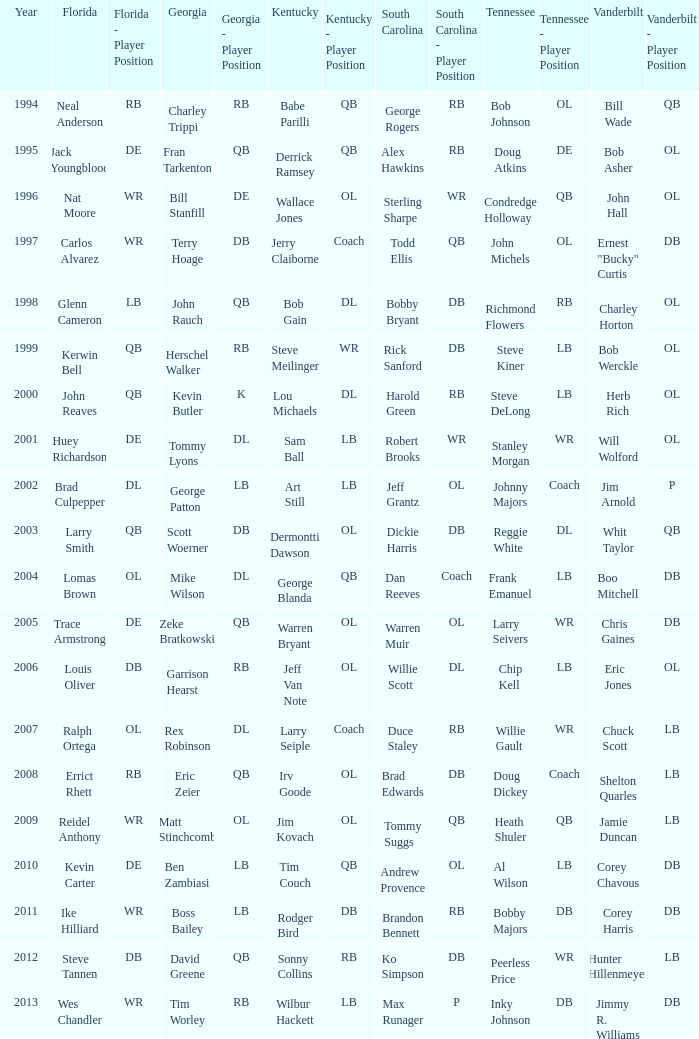What is the Tennessee that Georgia of kevin butler is in? Steve DeLong. 